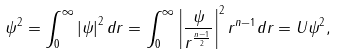Convert formula to latex. <formula><loc_0><loc_0><loc_500><loc_500>\| \psi \| ^ { 2 } = \int _ { 0 } ^ { \infty } \left | \psi \right | ^ { 2 } d r = \int _ { 0 } ^ { \infty } \left | \frac { \psi } { r ^ { \frac { n - 1 } { 2 } } } \right | ^ { 2 } r ^ { n - 1 } d r = \| U \psi \| ^ { 2 } ,</formula> 